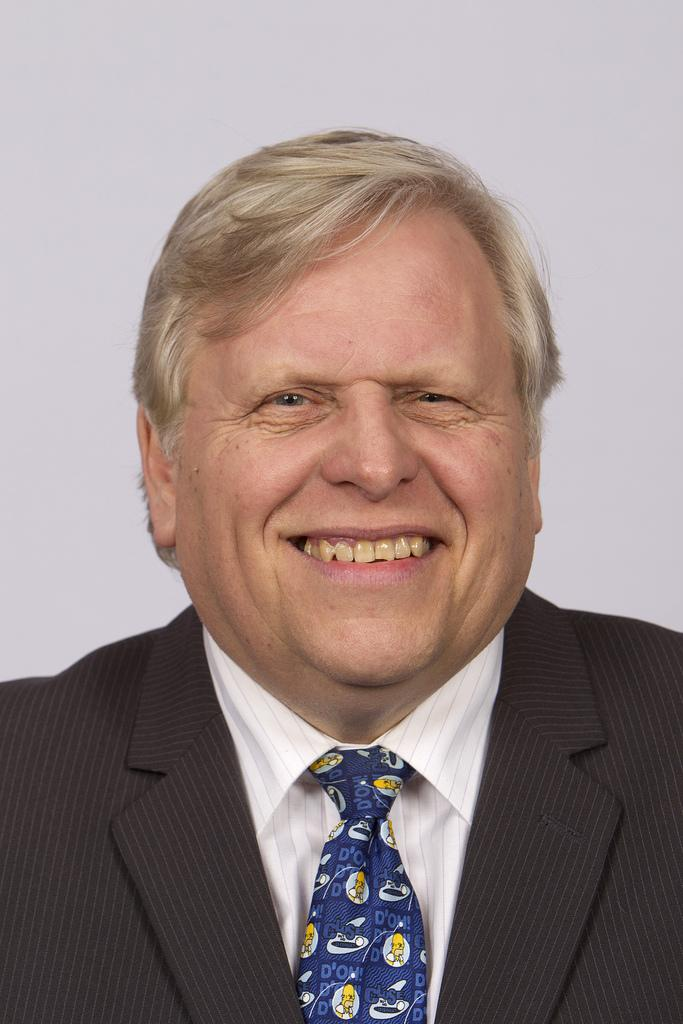What is the main subject of the image? There is a person in the image. What is the person's facial expression? The person is smiling. What color is the background of the image? The background of the image is white. How many shoes can be seen in the image? There are no shoes visible in the image; it only features a person with a white background. 